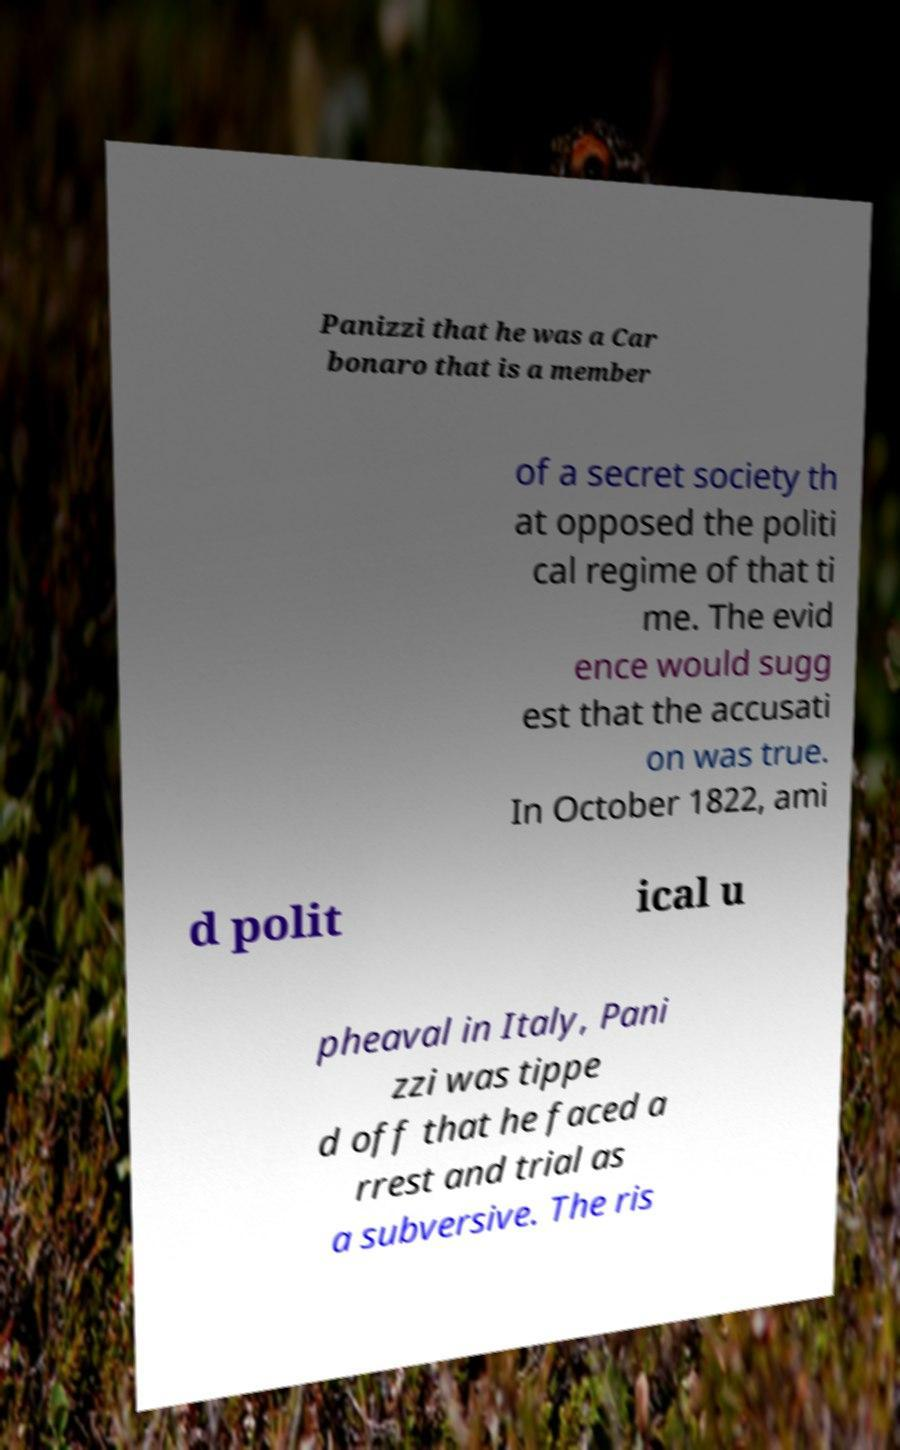There's text embedded in this image that I need extracted. Can you transcribe it verbatim? Panizzi that he was a Car bonaro that is a member of a secret society th at opposed the politi cal regime of that ti me. The evid ence would sugg est that the accusati on was true. In October 1822, ami d polit ical u pheaval in Italy, Pani zzi was tippe d off that he faced a rrest and trial as a subversive. The ris 